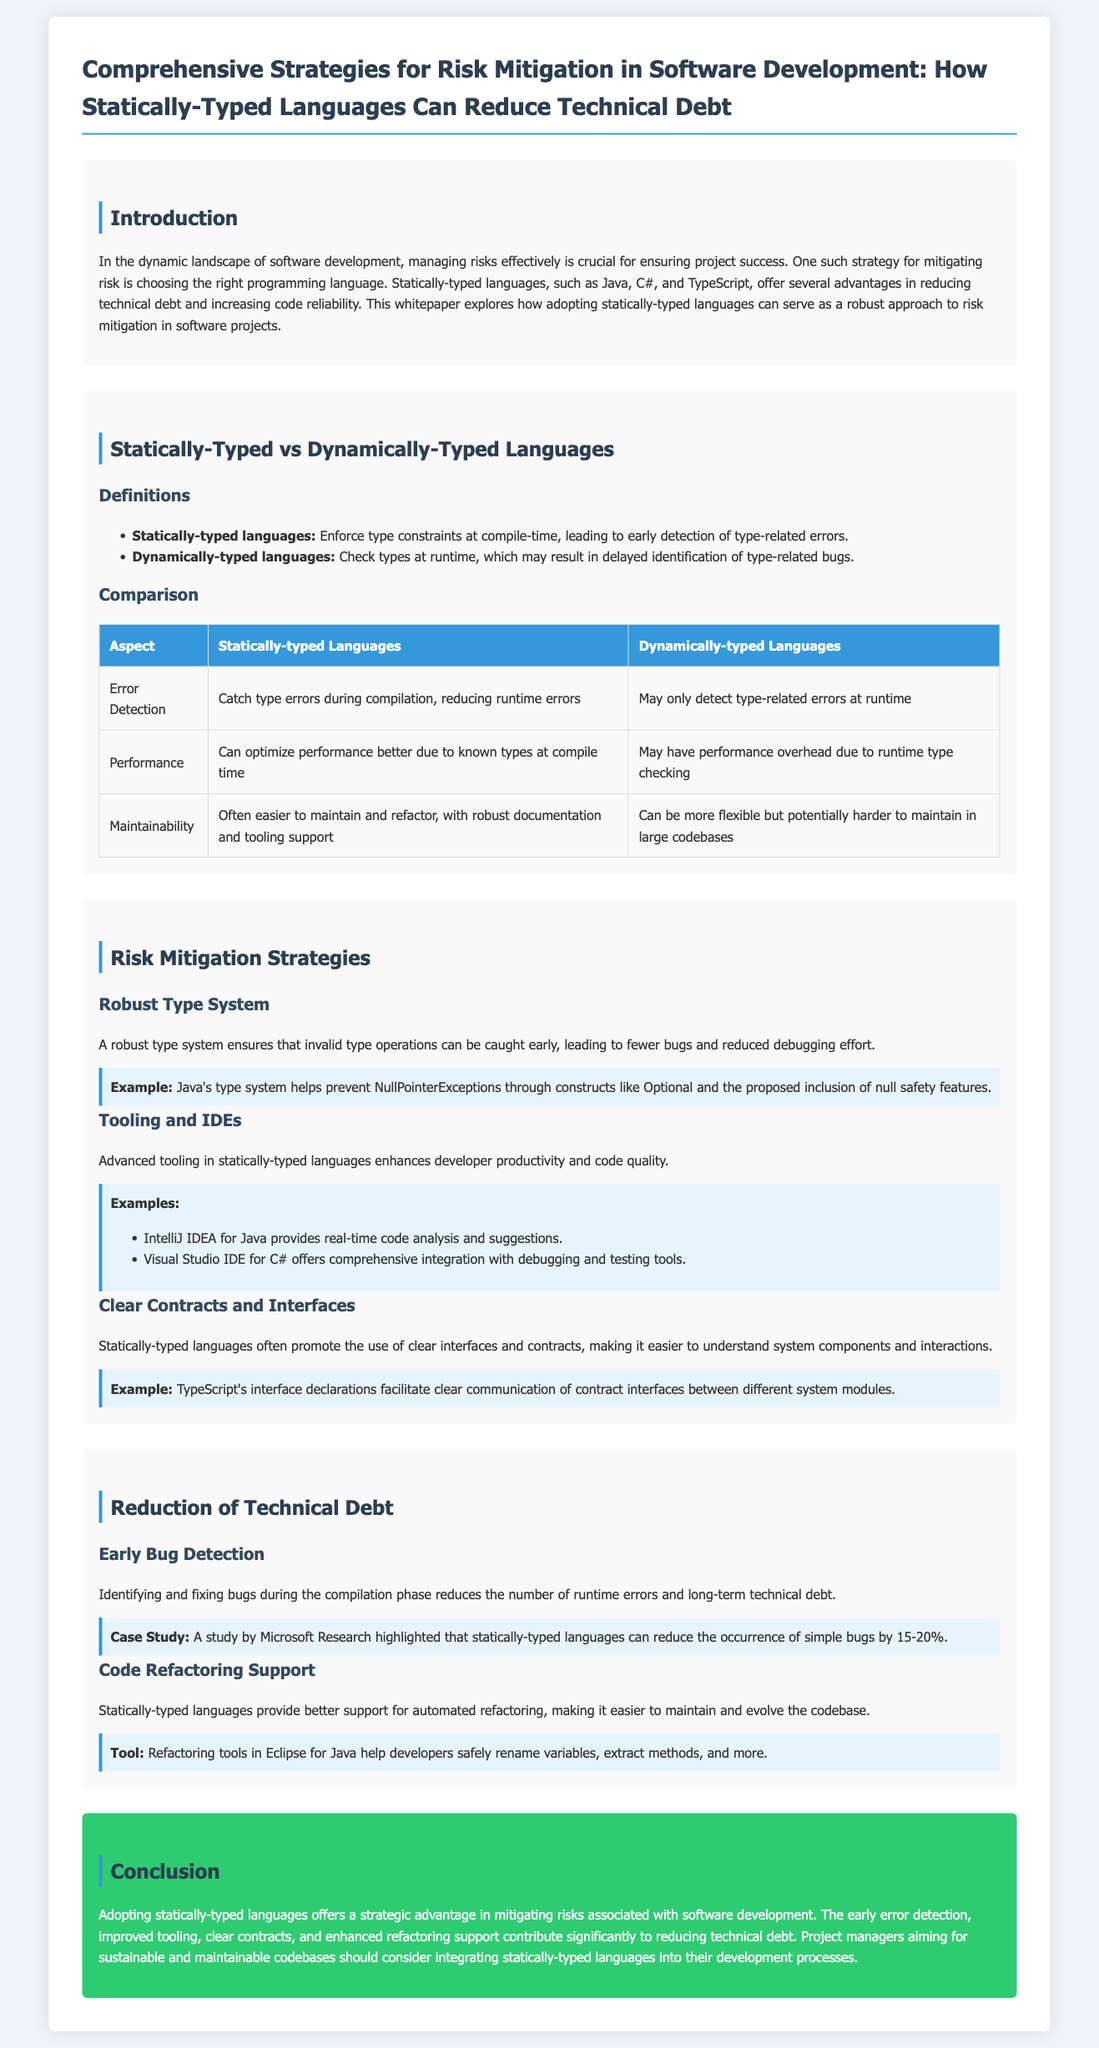What is the title of the whitepaper? The title is specified in the document header, which presents the main theme of the work.
Answer: Comprehensive Strategies for Risk Mitigation in Software Development: How Statically-Typed Languages Can Reduce Technical Debt What are two examples of statically-typed languages mentioned? The document lists Java, C#, and TypeScript as examples of statically-typed languages.
Answer: Java, C# What is one advantage of statically-typed languages in terms of error detection? The document states that statically-typed languages catch type errors during compilation, which is an early detection feature.
Answer: Catch type errors during compilation Which IDE is mentioned for Java in enhancing developer productivity? The document specifically highlights the IntelliJ IDEA for its real-time code analysis and suggestions for Java developers.
Answer: IntelliJ IDEA What percentage of simple bugs can statically-typed languages reduce according to the case study? The case study referenced in the document reports that statically-typed languages can reduce the occurrence of simple bugs by a range specified in percentage.
Answer: 15-20% What is a key feature of a robust type system as described in the document? The document emphasizes that a robust type system ensures early detection of invalid type operations, which leads to fewer bugs and reduced debugging efforts.
Answer: Early detection of invalid type operations Which section discusses the benefits of clear contracts and interfaces? The section explicitly addresses the advantages of using clear interfaces and contracts in statically-typed languages.
Answer: Clear Contracts and Interfaces What conclusion does the document propose regarding statically-typed languages? The conclusion summarizes the overall benefits, suggesting that project managers should consider integrating statically-typed languages for sustainable codebases.
Answer: Mitigating risks associated with software development 